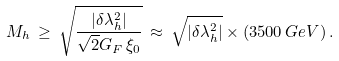Convert formula to latex. <formula><loc_0><loc_0><loc_500><loc_500>M _ { h } \, \geq \, \sqrt { \frac { | \delta \lambda _ { h } ^ { 2 } | } { \sqrt { 2 } G _ { F } \, \xi _ { 0 } } } \, \approx \, \sqrt { | \delta \lambda _ { h } ^ { 2 } | } \times ( 3 5 0 0 \, G e V ) \, .</formula> 